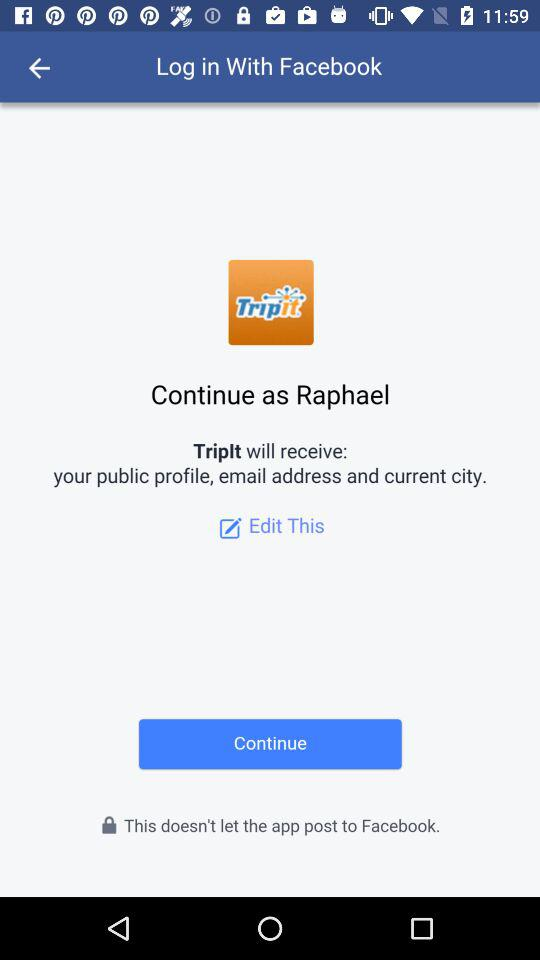What is the user name? The user name is Raphael. 